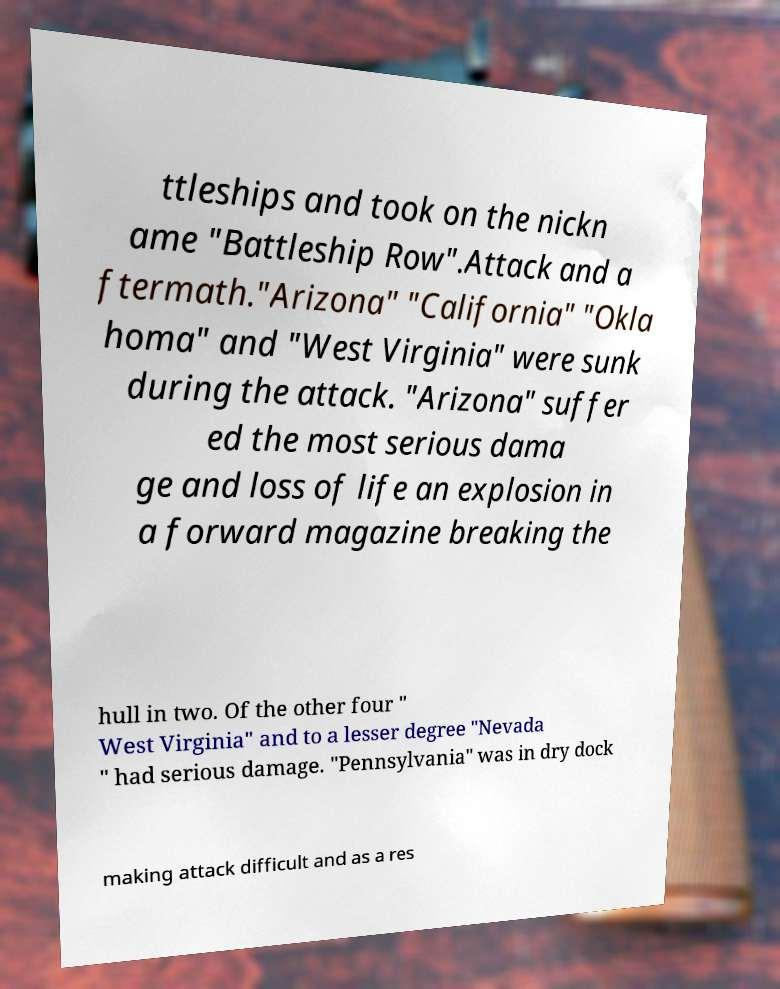Can you accurately transcribe the text from the provided image for me? ttleships and took on the nickn ame "Battleship Row".Attack and a ftermath."Arizona" "California" "Okla homa" and "West Virginia" were sunk during the attack. "Arizona" suffer ed the most serious dama ge and loss of life an explosion in a forward magazine breaking the hull in two. Of the other four " West Virginia" and to a lesser degree "Nevada " had serious damage. "Pennsylvania" was in dry dock making attack difficult and as a res 